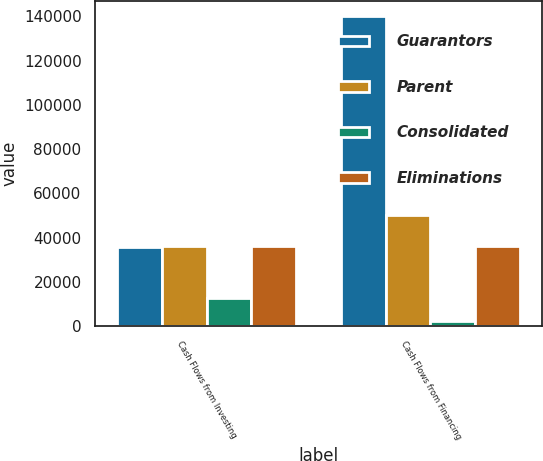<chart> <loc_0><loc_0><loc_500><loc_500><stacked_bar_chart><ecel><fcel>Cash Flows from Investing<fcel>Cash Flows from Financing<nl><fcel>Guarantors<fcel>35663<fcel>140118<nl><fcel>Parent<fcel>36239<fcel>50391<nl><fcel>Consolidated<fcel>12876<fcel>2311<nl><fcel>Eliminations<fcel>36239<fcel>36239<nl></chart> 